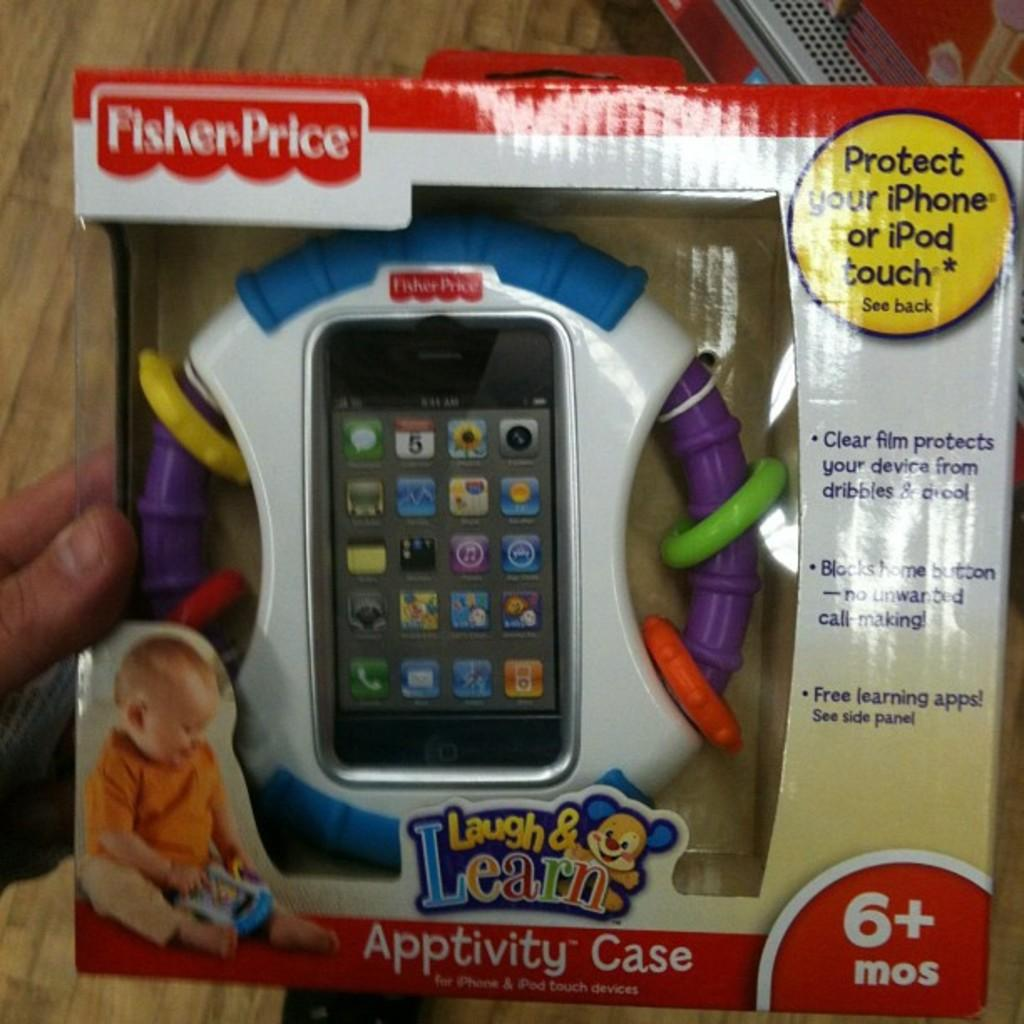<image>
Render a clear and concise summary of the photo. a children's toy from the company laugh and learn 